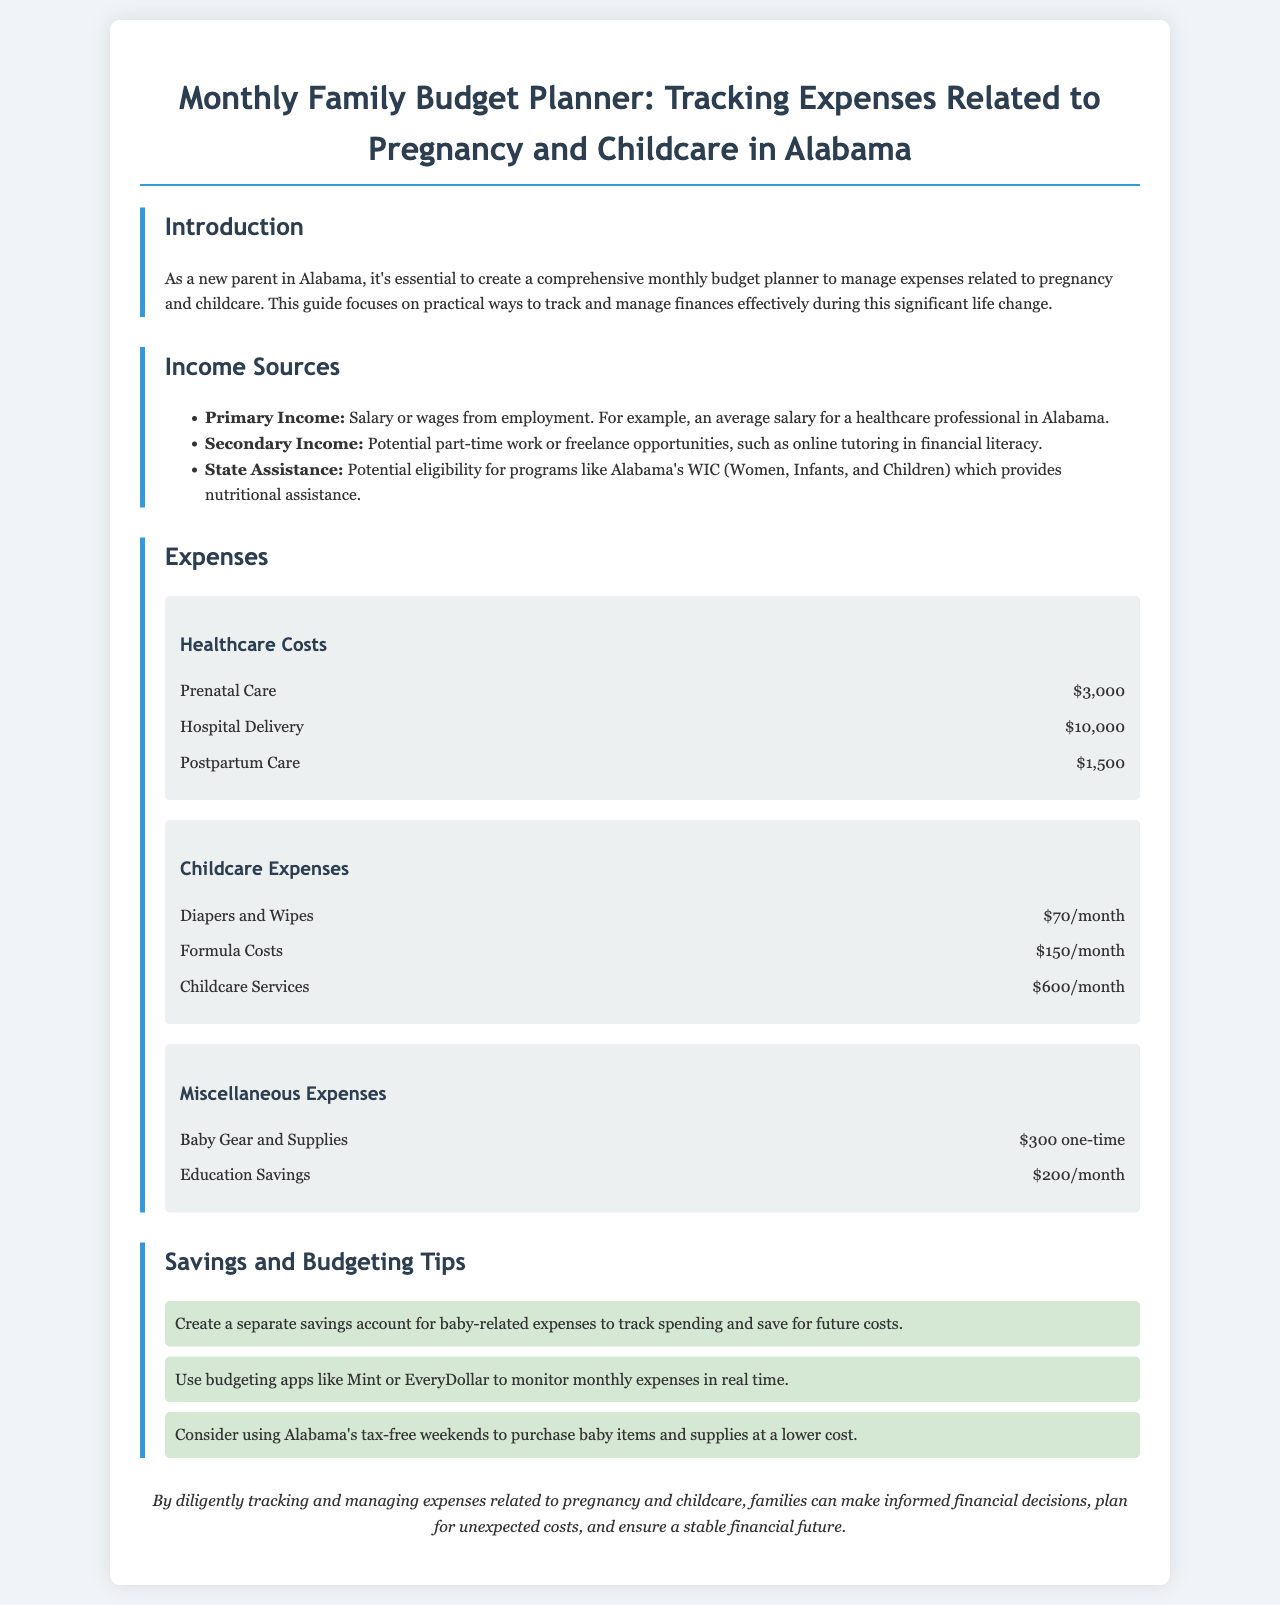what is the total cost for prenatal care? The document lists the cost of prenatal care as $3,000.
Answer: $3,000 what monthly expense is associated with formula costs? The document specifies that formula costs are $150 per month.
Answer: $150/month how much is allocated for childcare services monthly? The document indicates that childcare services cost $600 per month.
Answer: $600/month what is the one-time expense for baby gear and supplies? The document states that baby gear and supplies are a one-time expense of $300.
Answer: $300 one-time how much is suggested for education savings each month? The document mentions an allocation of $200 per month for education savings.
Answer: $200/month what is a tip for tracking baby-related expenses? One of the tips suggests creating a separate savings account for baby-related expenses.
Answer: Separate savings account what type of apps are recommended for budgeting? The document recommends using budgeting apps like Mint or EveryDollar.
Answer: Mint or EveryDollar what is the total of healthcare costs listed in the document? To find the total healthcare costs, one would sum prenatal care, hospital delivery, and postpartum care: $3,000 + $10,000 + $1,500 = $14,500.
Answer: $14,500 which state assistance program is mentioned? The document refers to Alabama's WIC (Women, Infants, and Children).
Answer: WIC 